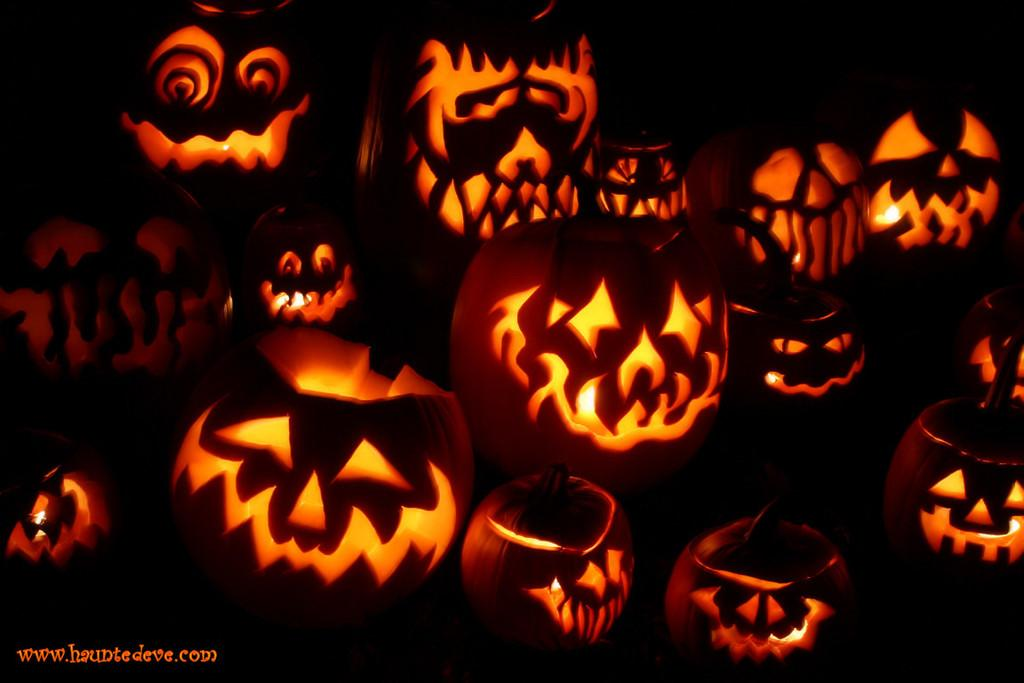What is depicted in the image? There are pumpkin carvings in the image. Are there any additional elements in the image besides the pumpkin carvings? Yes, there are lights in the image. Can you describe the location of the watermark in the image? The watermark is in the left side bottom corner of the image. What type of rock can be seen in the image? There is no rock present in the image; it features pumpkin carvings and lights. Can you describe the cable used to connect the lights in the image? There is no cable visible in the image; only the lights are present. 